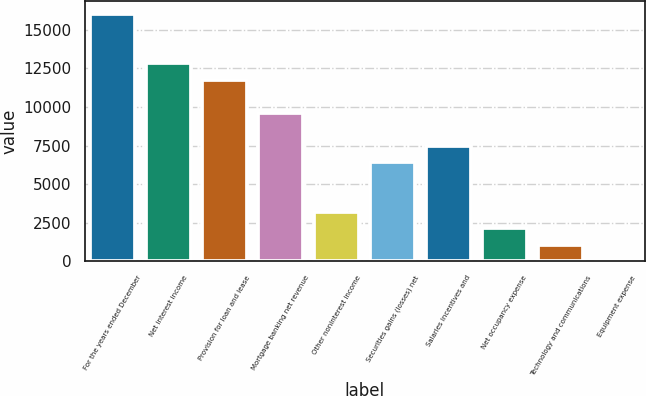<chart> <loc_0><loc_0><loc_500><loc_500><bar_chart><fcel>For the years ended December<fcel>Net interest income<fcel>Provision for loan and lease<fcel>Mortgage banking net revenue<fcel>Other noninterest income<fcel>Securities gains (losses) net<fcel>Salaries incentives and<fcel>Net occupancy expense<fcel>Technology and communications<fcel>Equipment expense<nl><fcel>16048<fcel>12838.6<fcel>11768.8<fcel>9629.2<fcel>3210.4<fcel>6419.8<fcel>7489.6<fcel>2140.6<fcel>1070.8<fcel>1<nl></chart> 